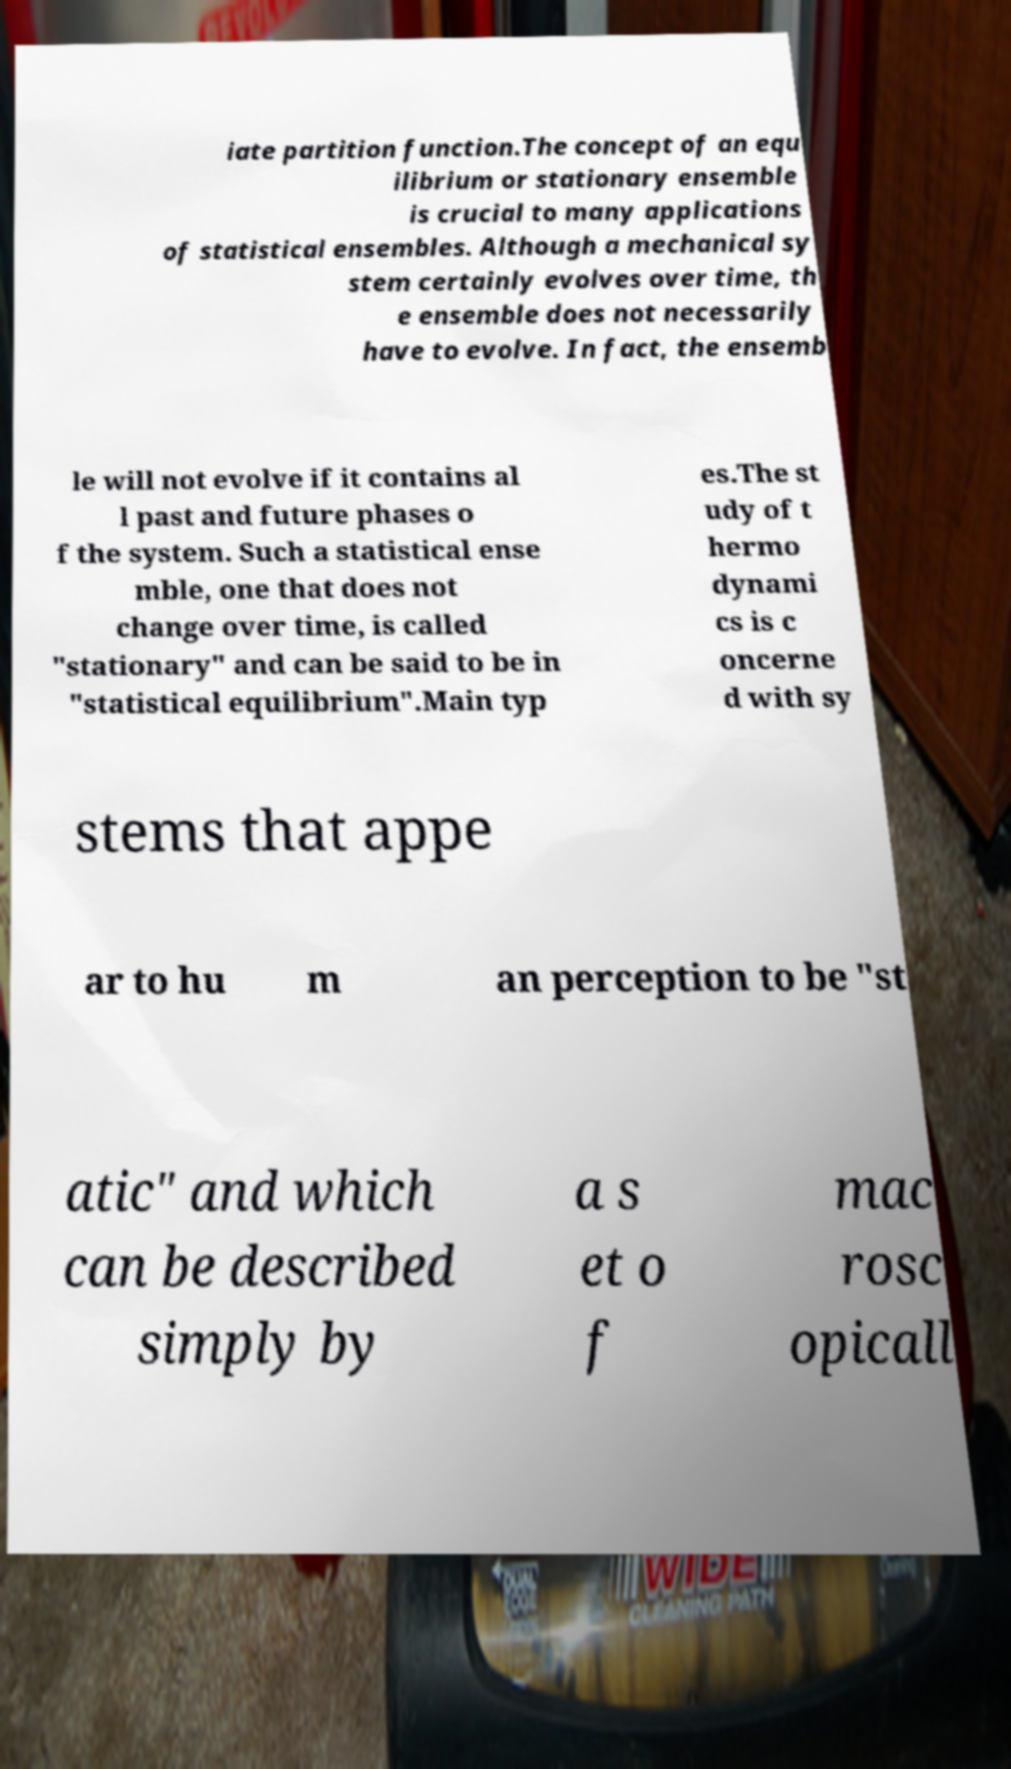Can you read and provide the text displayed in the image?This photo seems to have some interesting text. Can you extract and type it out for me? iate partition function.The concept of an equ ilibrium or stationary ensemble is crucial to many applications of statistical ensembles. Although a mechanical sy stem certainly evolves over time, th e ensemble does not necessarily have to evolve. In fact, the ensemb le will not evolve if it contains al l past and future phases o f the system. Such a statistical ense mble, one that does not change over time, is called "stationary" and can be said to be in "statistical equilibrium".Main typ es.The st udy of t hermo dynami cs is c oncerne d with sy stems that appe ar to hu m an perception to be "st atic" and which can be described simply by a s et o f mac rosc opicall 